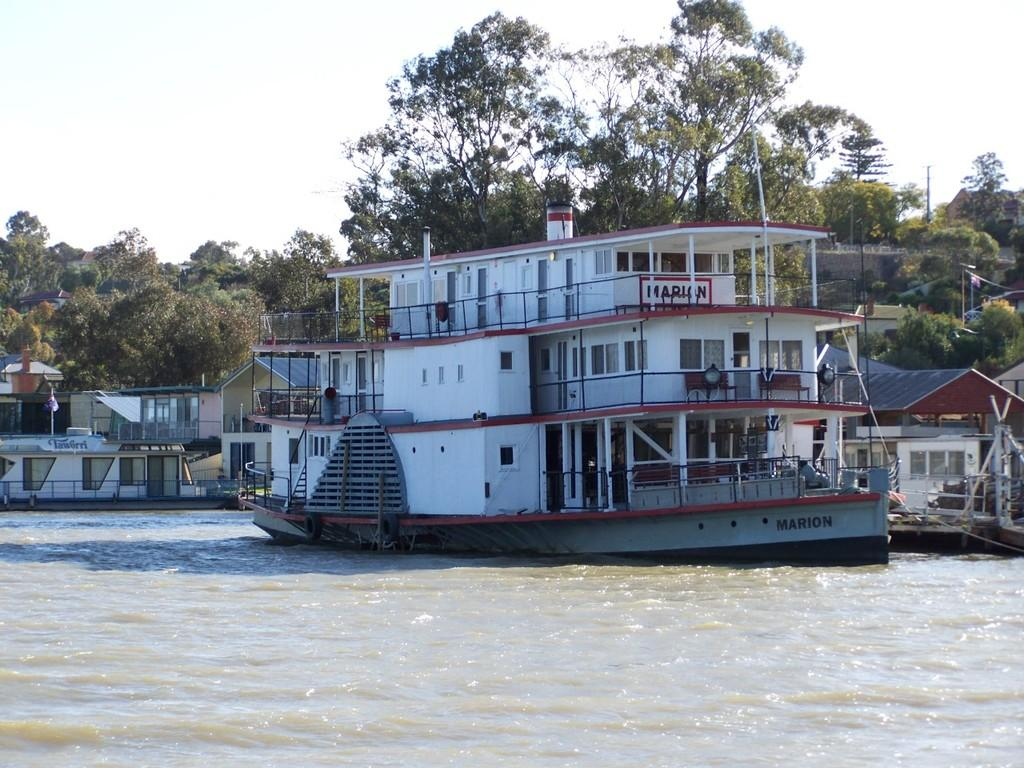What is the main subject of the image? The main subject of the image is ships. Where are the ships located? The ships are in a river. What can be seen in the background of the image? There are trees and the sky visible in the background of the image. What type of brass instrument is being played on the ship in the image? There is no brass instrument or any indication of music being played in the image. 